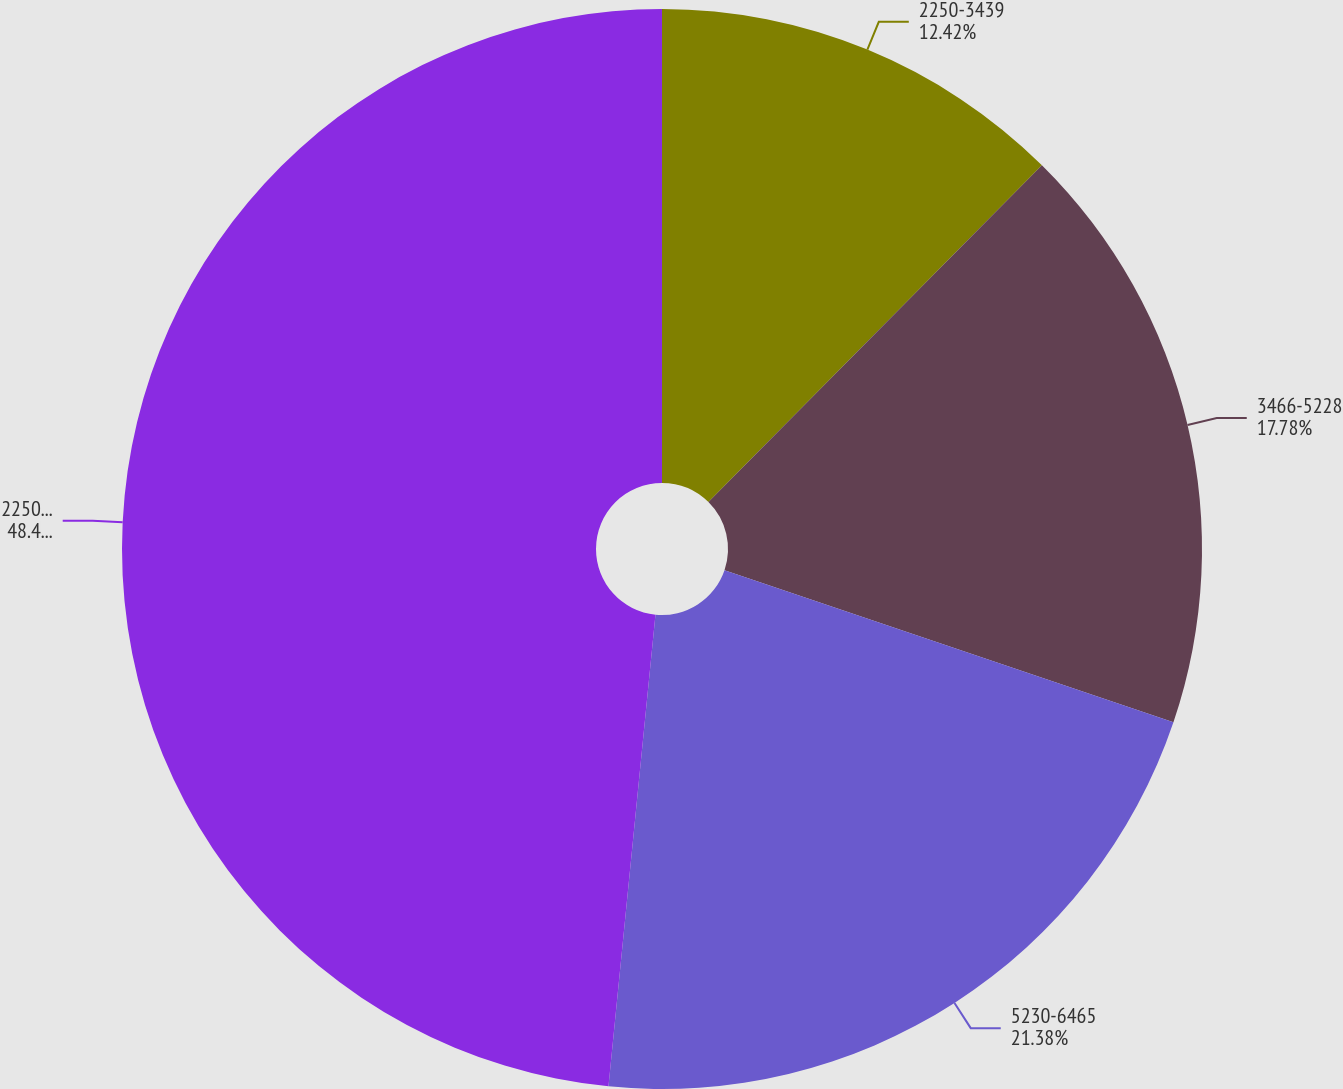Convert chart. <chart><loc_0><loc_0><loc_500><loc_500><pie_chart><fcel>2250-3439<fcel>3466-5228<fcel>5230-6465<fcel>2250-6465<nl><fcel>12.42%<fcel>17.78%<fcel>21.38%<fcel>48.42%<nl></chart> 